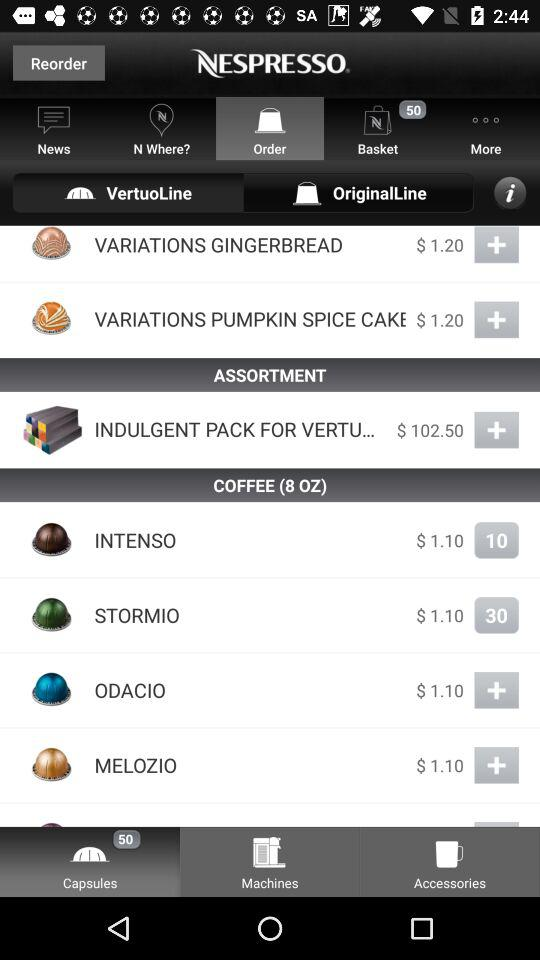How much is the price of "INTENSO"? The price of "INTENSO" is $1.10. 